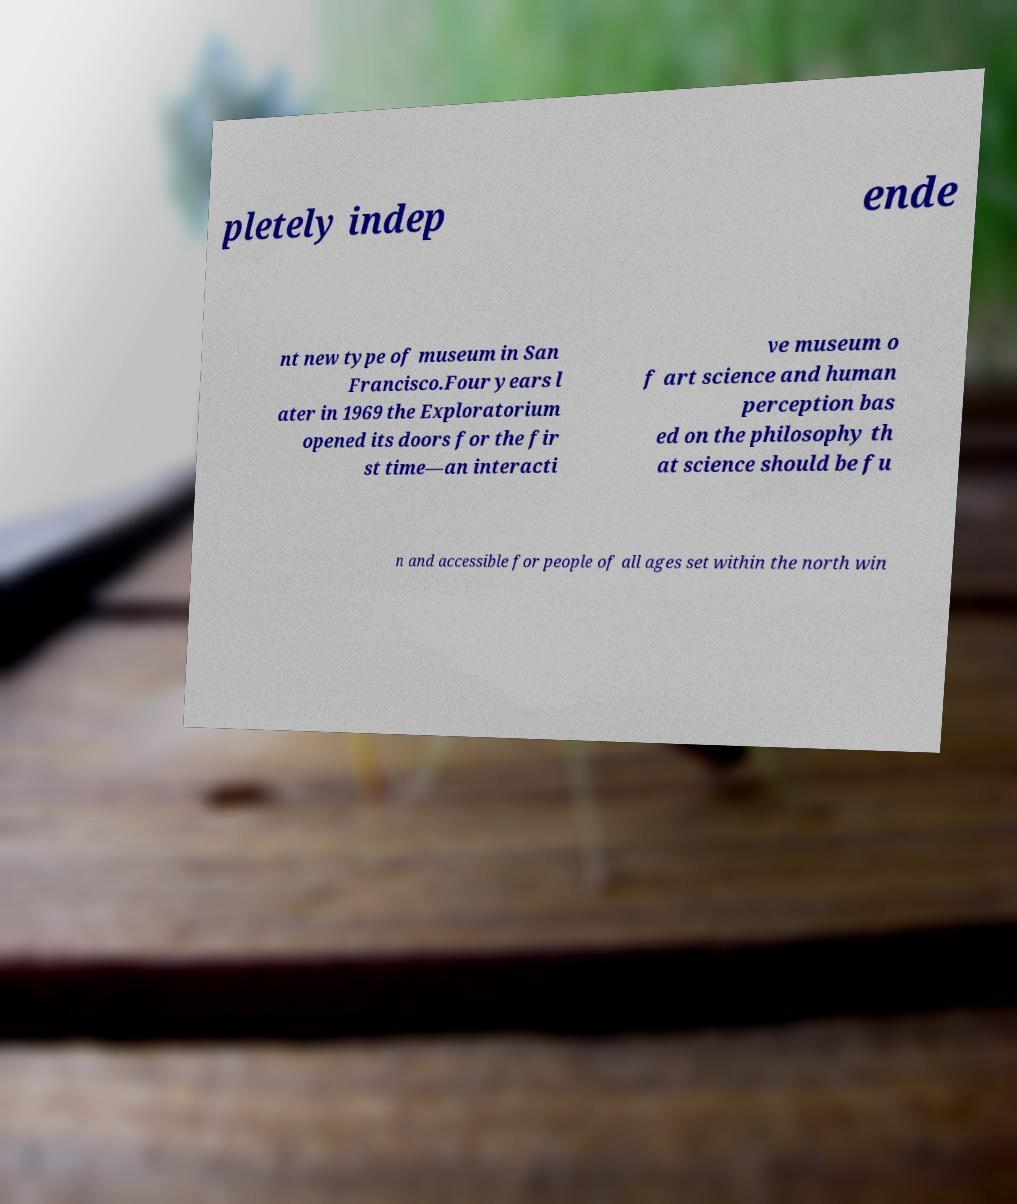Can you accurately transcribe the text from the provided image for me? pletely indep ende nt new type of museum in San Francisco.Four years l ater in 1969 the Exploratorium opened its doors for the fir st time—an interacti ve museum o f art science and human perception bas ed on the philosophy th at science should be fu n and accessible for people of all ages set within the north win 